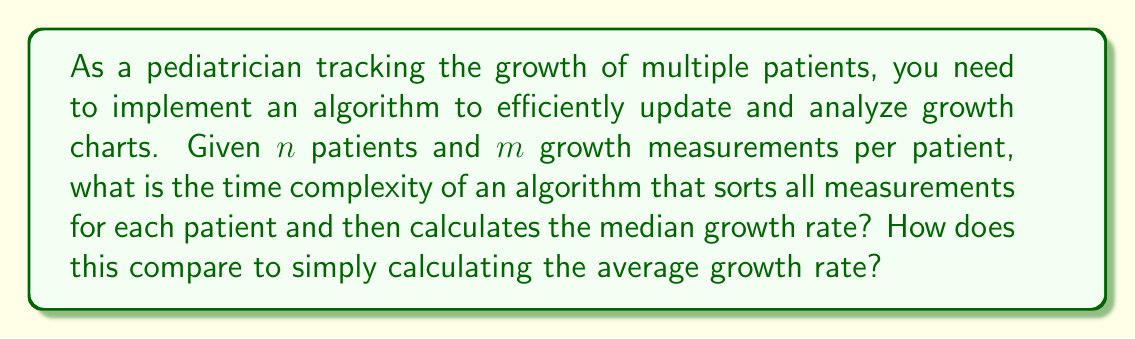Could you help me with this problem? Let's break this down step by step:

1. Sorting measurements for each patient:
   - We have $n$ patients, each with $m$ measurements.
   - Using an efficient sorting algorithm like Merge Sort or Quick Sort, sorting $m$ items takes $O(m \log m)$ time.
   - We need to do this for all $n$ patients, so the total time for sorting is $O(n \cdot m \log m)$.

2. Calculating the median growth rate:
   - After sorting, finding the median is a constant time operation $O(1)$ for each patient.
   - We do this for all $n$ patients, so it takes $O(n)$ time.

3. Total time complexity for median calculation:
   $O(n \cdot m \log m + n) = O(n \cdot m \log m)$

4. Calculating the average growth rate:
   - This requires summing all measurements and dividing by the count.
   - We need to iterate through all measurements once: $O(n \cdot m)$
   - Division is a constant time operation: $O(1)$
   - Total time for average: $O(n \cdot m)$

Comparison:
- Median calculation: $O(n \cdot m \log m)$
- Average calculation: $O(n \cdot m)$

The average calculation is asymptotically faster than the median calculation due to the absence of the $\log m$ factor. However, the median might provide a more robust measure of central tendency, especially in the presence of outliers or skewed data, which is common in pediatric growth patterns.
Answer: The time complexity for calculating the median growth rate is $O(n \cdot m \log m)$, which is asymptotically slower than calculating the average growth rate, which has a time complexity of $O(n \cdot m)$. 